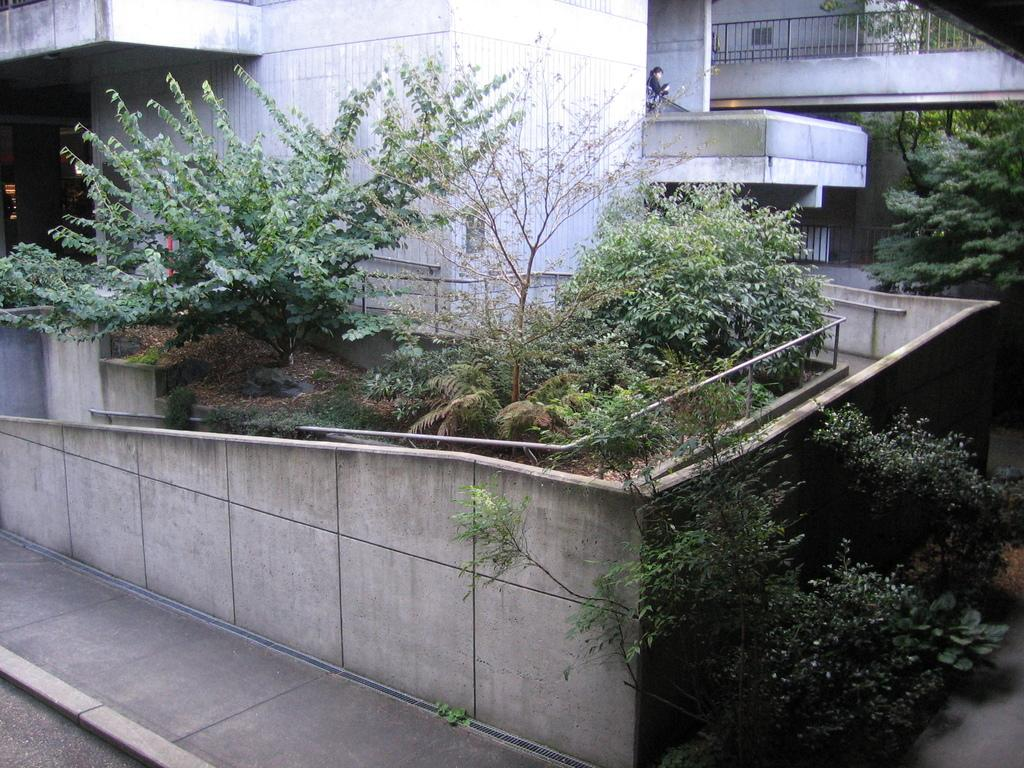What type of path is visible in the image? There is a road in the image. What is located alongside the road? There is a sidewalk in the image. What type of natural elements can be seen in the image? There are plants and trees in the image. What type of man-made structures are present in the image? There are buildings in the image. Can you describe the presence of people in the image? There is a person in the background of the image. What type of thread is being used by the person in the image? There is no thread visible in the image, as the person is in the background and not performing any activity that would involve thread. 